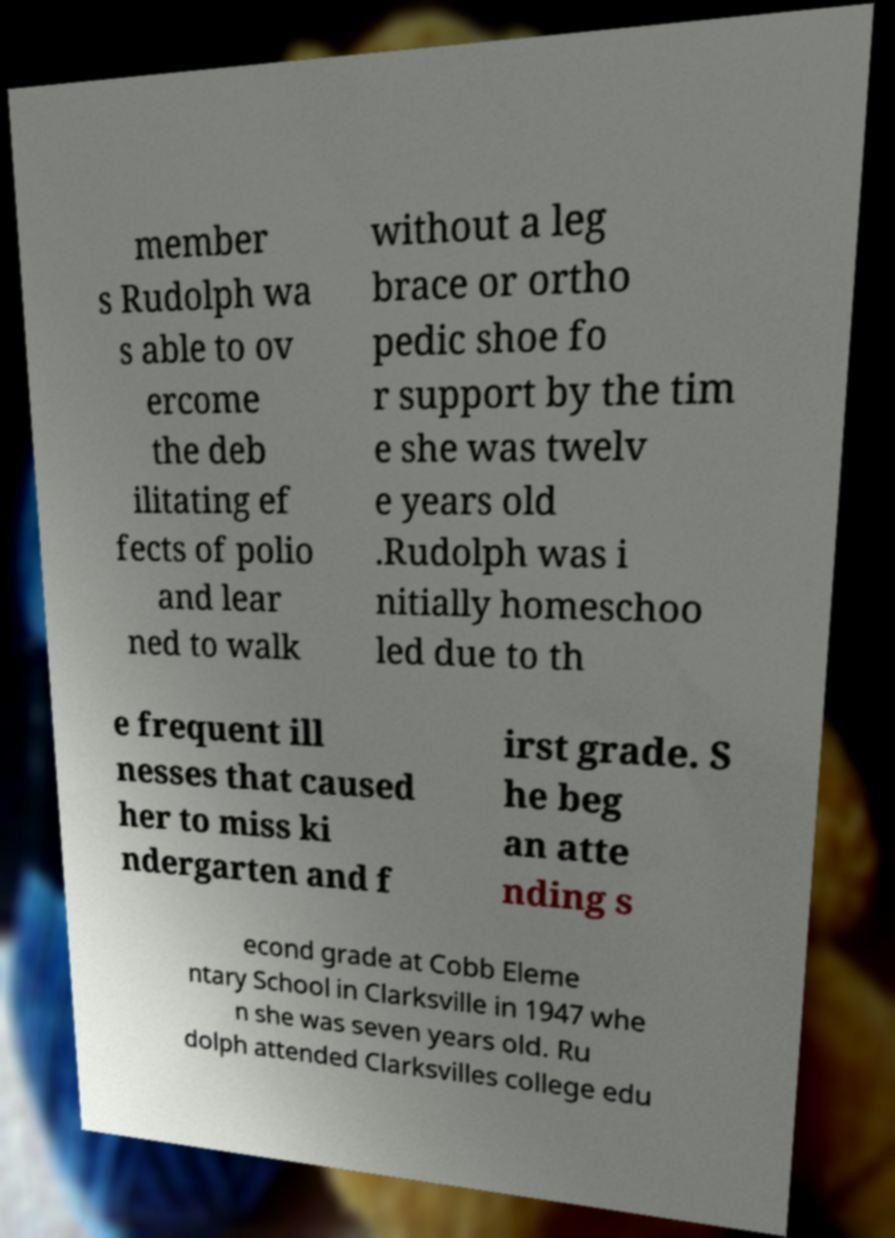There's text embedded in this image that I need extracted. Can you transcribe it verbatim? member s Rudolph wa s able to ov ercome the deb ilitating ef fects of polio and lear ned to walk without a leg brace or ortho pedic shoe fo r support by the tim e she was twelv e years old .Rudolph was i nitially homeschoo led due to th e frequent ill nesses that caused her to miss ki ndergarten and f irst grade. S he beg an atte nding s econd grade at Cobb Eleme ntary School in Clarksville in 1947 whe n she was seven years old. Ru dolph attended Clarksvilles college edu 